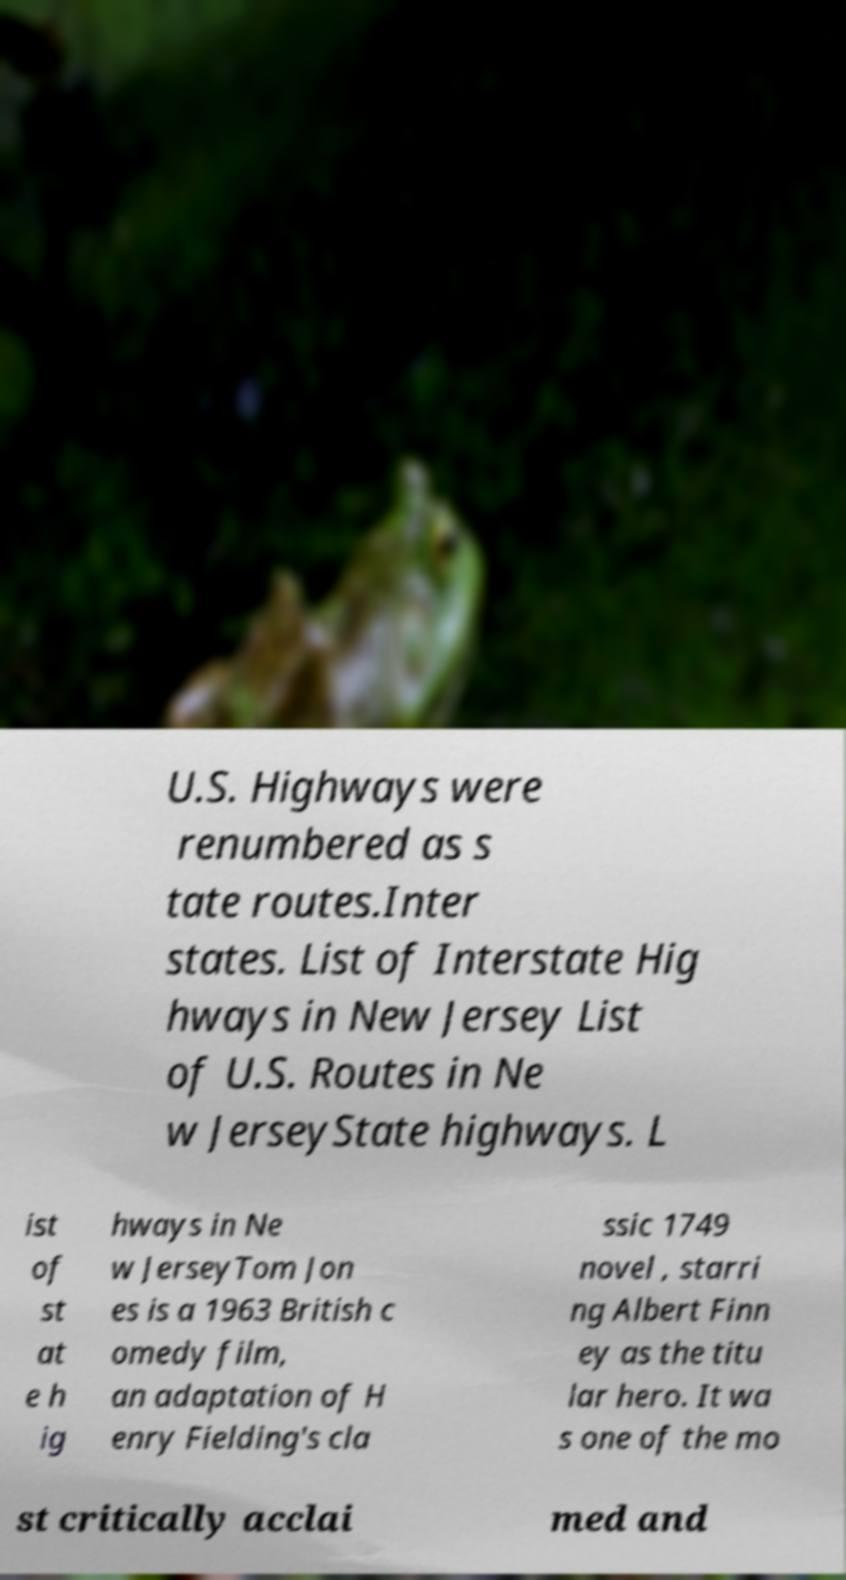There's text embedded in this image that I need extracted. Can you transcribe it verbatim? U.S. Highways were renumbered as s tate routes.Inter states. List of Interstate Hig hways in New Jersey List of U.S. Routes in Ne w JerseyState highways. L ist of st at e h ig hways in Ne w JerseyTom Jon es is a 1963 British c omedy film, an adaptation of H enry Fielding's cla ssic 1749 novel , starri ng Albert Finn ey as the titu lar hero. It wa s one of the mo st critically acclai med and 